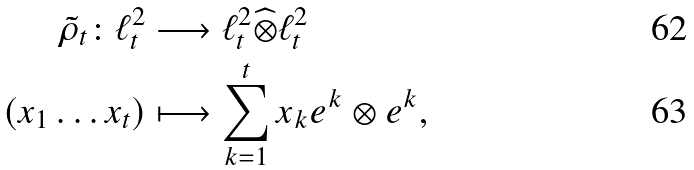Convert formula to latex. <formula><loc_0><loc_0><loc_500><loc_500>\tilde { \rho } _ { t } \colon \ell ^ { 2 } _ { t } & \longrightarrow \ell ^ { 2 } _ { t } \widehat { \otimes } \ell ^ { 2 } _ { t } \\ ( x _ { 1 } \dots x _ { t } ) & \longmapsto \sum _ { k = 1 } ^ { t } x _ { k } e ^ { k } \otimes e ^ { k } ,</formula> 